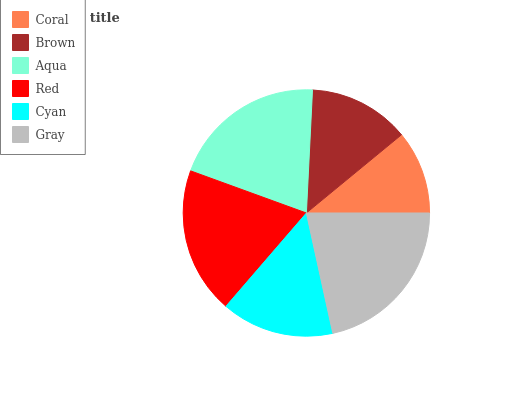Is Coral the minimum?
Answer yes or no. Yes. Is Gray the maximum?
Answer yes or no. Yes. Is Brown the minimum?
Answer yes or no. No. Is Brown the maximum?
Answer yes or no. No. Is Brown greater than Coral?
Answer yes or no. Yes. Is Coral less than Brown?
Answer yes or no. Yes. Is Coral greater than Brown?
Answer yes or no. No. Is Brown less than Coral?
Answer yes or no. No. Is Red the high median?
Answer yes or no. Yes. Is Cyan the low median?
Answer yes or no. Yes. Is Brown the high median?
Answer yes or no. No. Is Red the low median?
Answer yes or no. No. 